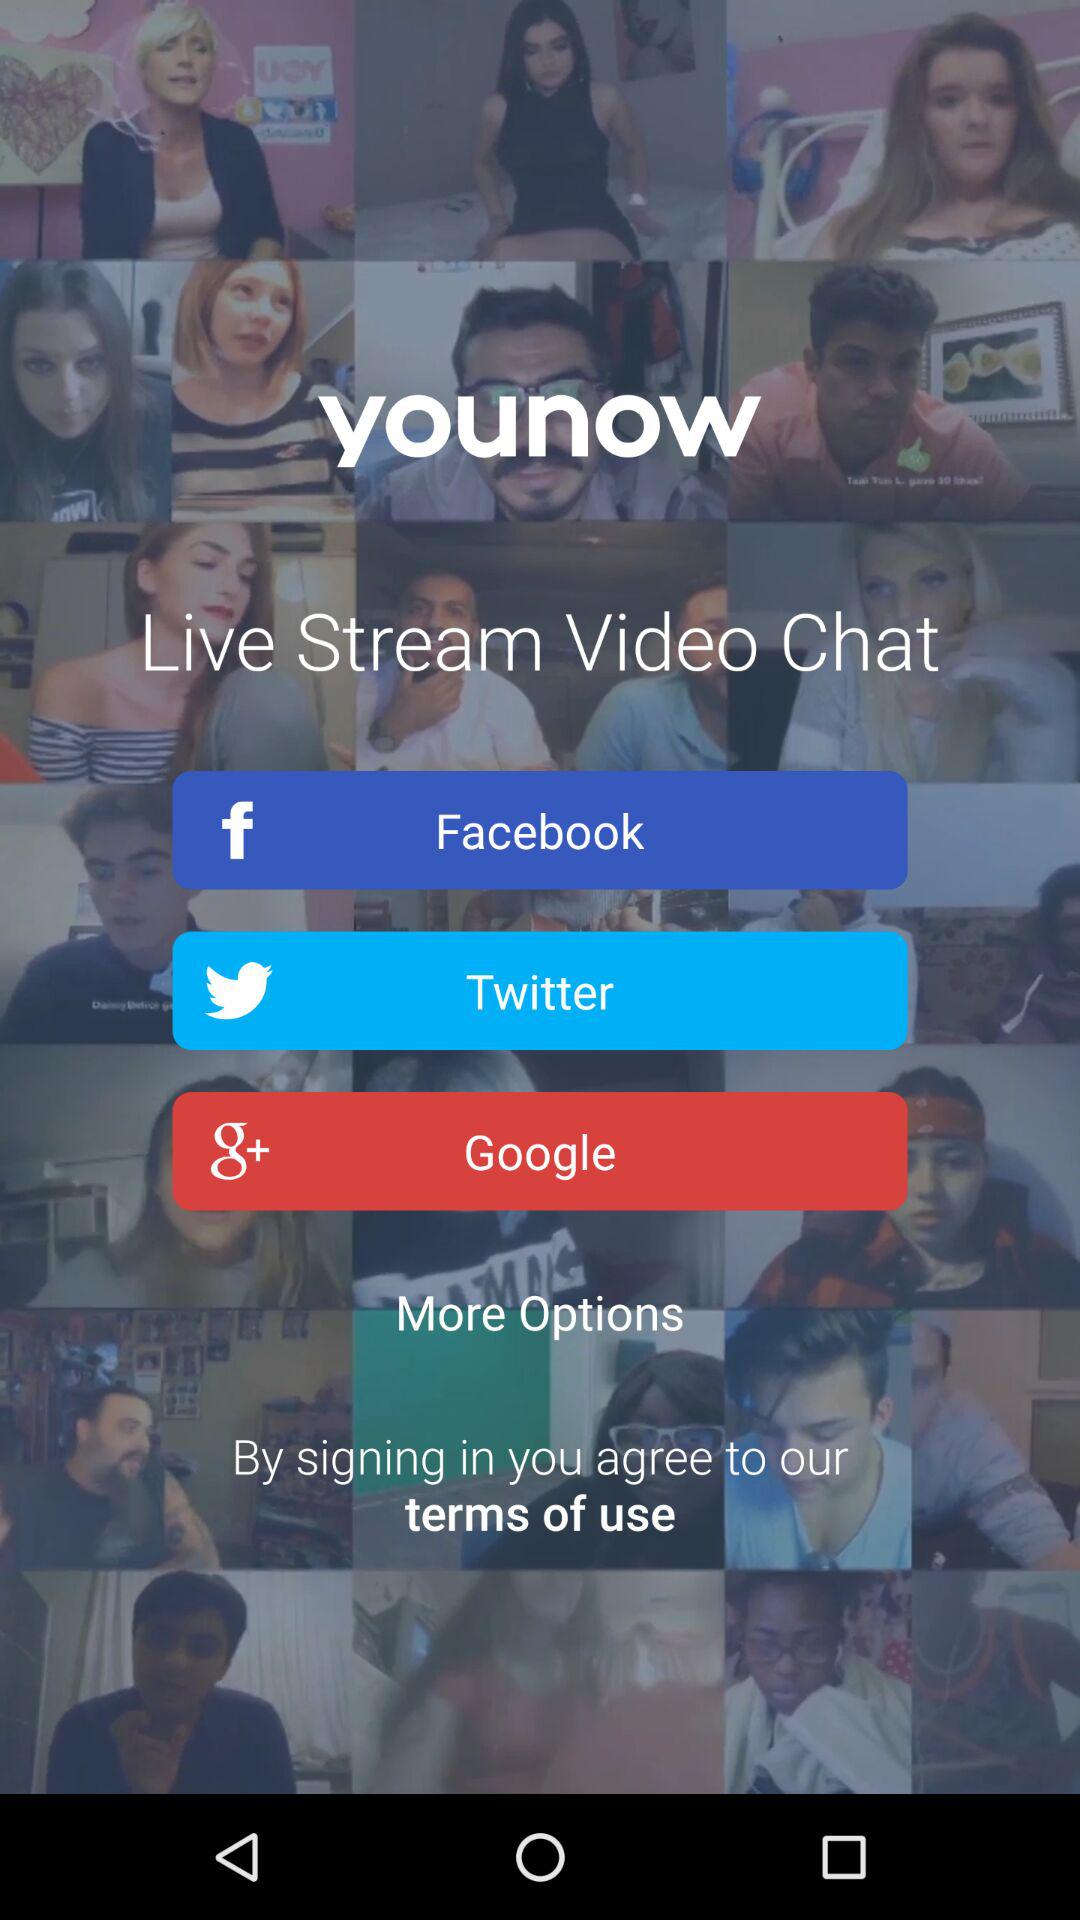What is the application name? The application name is "younow". 